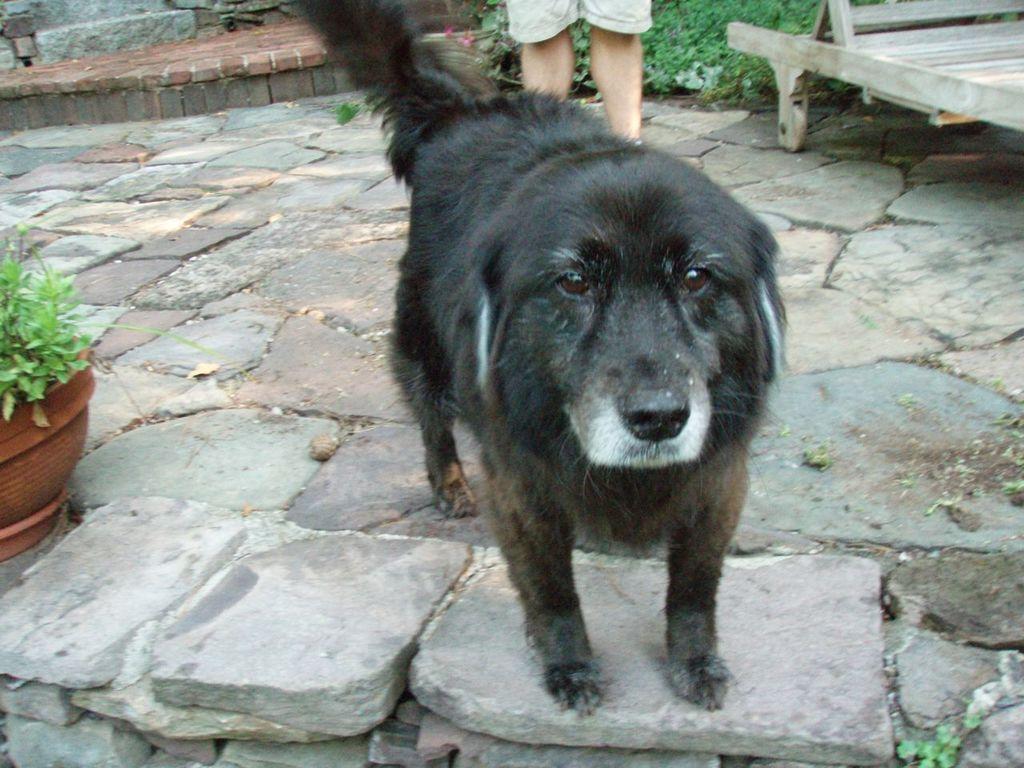How would you summarize this image in a sentence or two? In the image we can see there is a black colour dog who is standing on the road and behind him there is a person standing. 